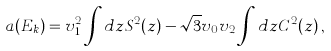Convert formula to latex. <formula><loc_0><loc_0><loc_500><loc_500>a ( E _ { k } ) = v _ { 1 } ^ { 2 } \int d z S ^ { 2 } ( z ) - \sqrt { 3 } v _ { 0 } v _ { 2 } \int d z C ^ { 2 } ( z ) \, ,</formula> 